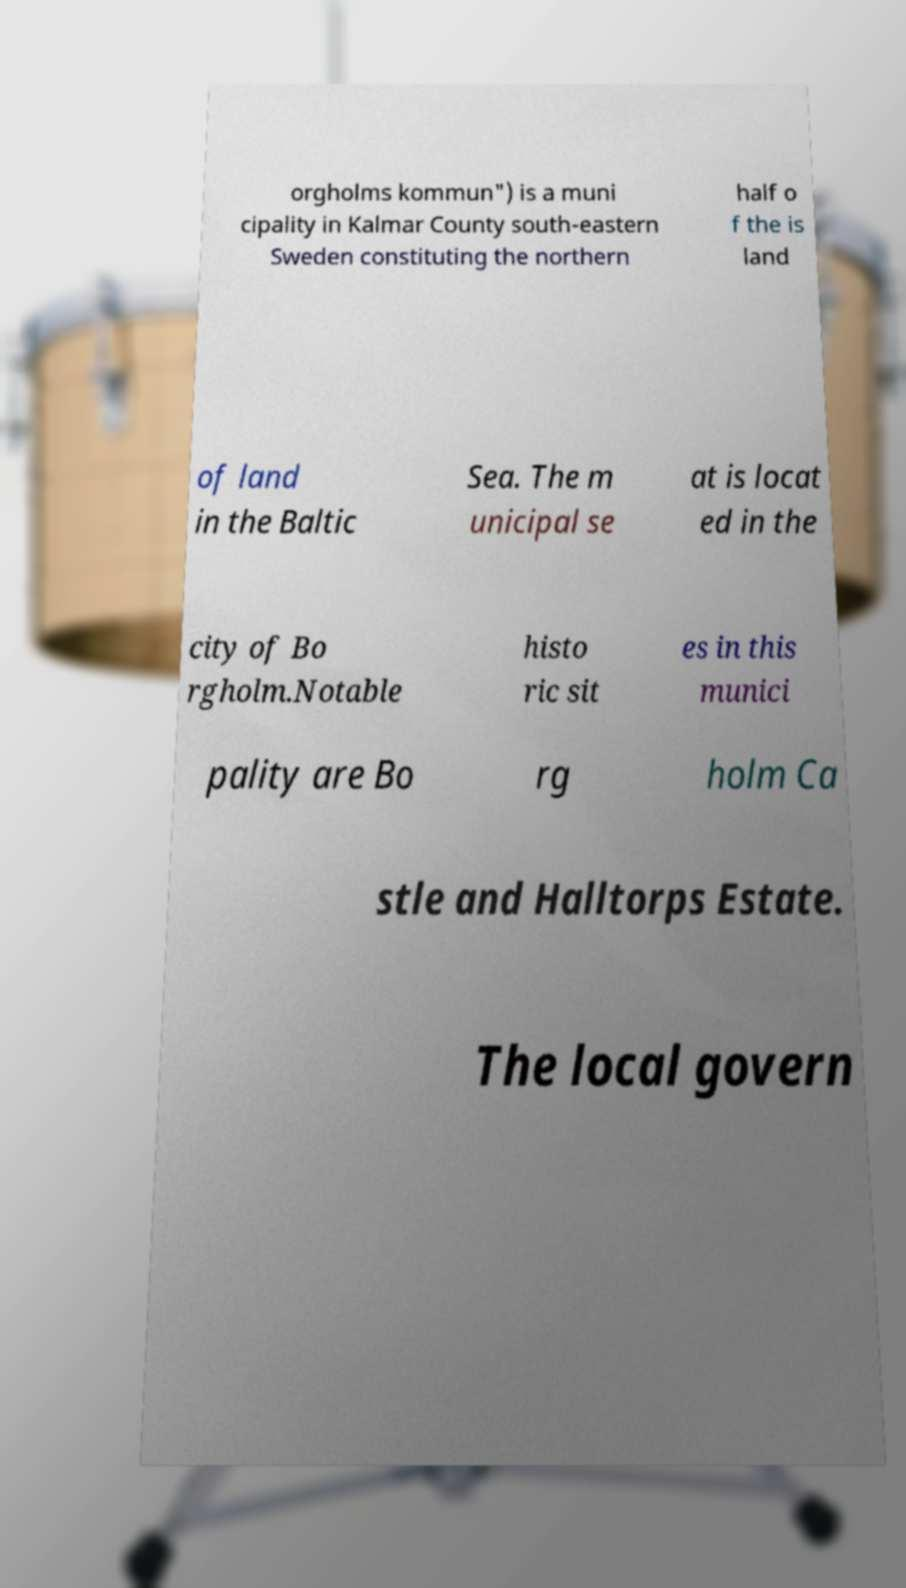Please identify and transcribe the text found in this image. orgholms kommun") is a muni cipality in Kalmar County south-eastern Sweden constituting the northern half o f the is land of land in the Baltic Sea. The m unicipal se at is locat ed in the city of Bo rgholm.Notable histo ric sit es in this munici pality are Bo rg holm Ca stle and Halltorps Estate. The local govern 